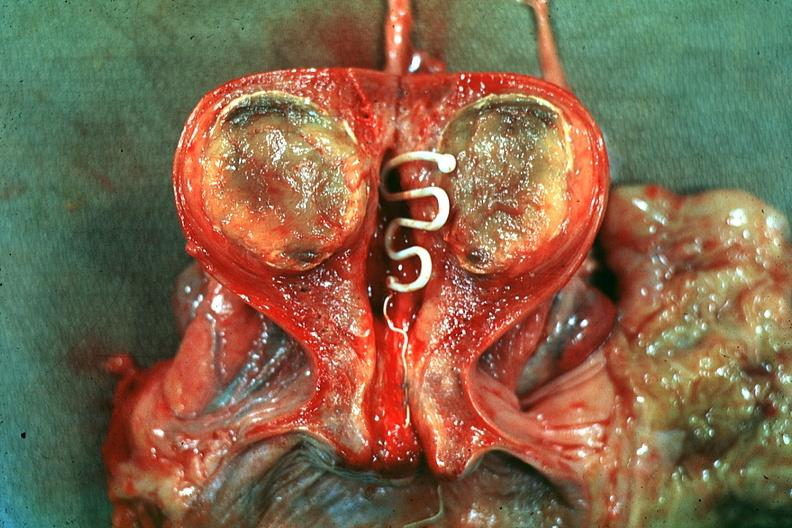s vasculature present?
Answer the question using a single word or phrase. No 